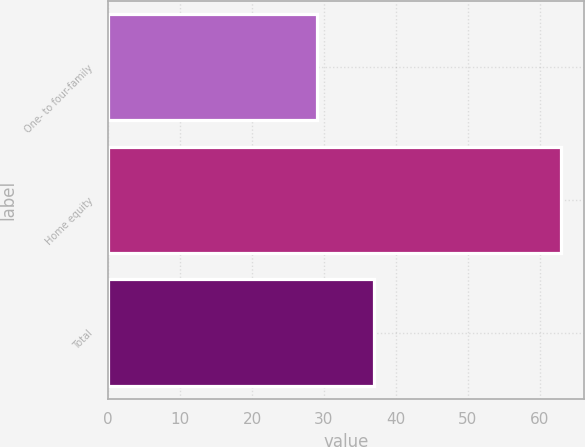Convert chart. <chart><loc_0><loc_0><loc_500><loc_500><bar_chart><fcel>One- to four-family<fcel>Home equity<fcel>Total<nl><fcel>29<fcel>63<fcel>37<nl></chart> 